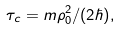Convert formula to latex. <formula><loc_0><loc_0><loc_500><loc_500>\tau _ { c } = m \rho _ { 0 } ^ { 2 } / ( 2 \hbar { ) } ,</formula> 